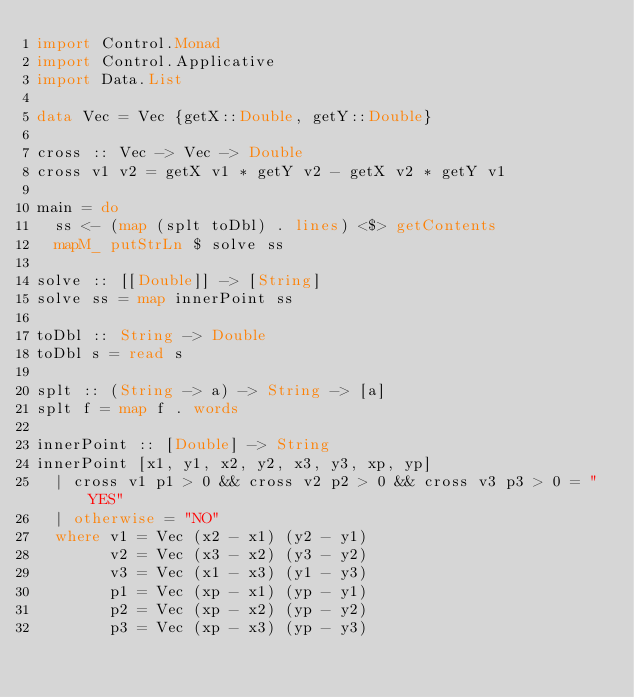Convert code to text. <code><loc_0><loc_0><loc_500><loc_500><_Haskell_>import Control.Monad
import Control.Applicative
import Data.List

data Vec = Vec {getX::Double, getY::Double}

cross :: Vec -> Vec -> Double
cross v1 v2 = getX v1 * getY v2 - getX v2 * getY v1

main = do
  ss <- (map (splt toDbl) . lines) <$> getContents
  mapM_ putStrLn $ solve ss

solve :: [[Double]] -> [String]
solve ss = map innerPoint ss

toDbl :: String -> Double
toDbl s = read s

splt :: (String -> a) -> String -> [a]
splt f = map f . words

innerPoint :: [Double] -> String
innerPoint [x1, y1, x2, y2, x3, y3, xp, yp]
  | cross v1 p1 > 0 && cross v2 p2 > 0 && cross v3 p3 > 0 = "YES"
  | otherwise = "NO"
  where v1 = Vec (x2 - x1) (y2 - y1)
        v2 = Vec (x3 - x2) (y3 - y2)
        v3 = Vec (x1 - x3) (y1 - y3)
        p1 = Vec (xp - x1) (yp - y1)
        p2 = Vec (xp - x2) (yp - y2)
        p3 = Vec (xp - x3) (yp - y3)</code> 